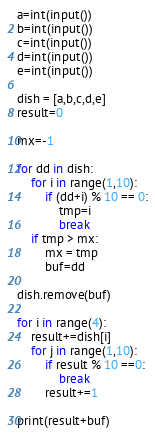Convert code to text. <code><loc_0><loc_0><loc_500><loc_500><_Python_>a=int(input())
b=int(input())
c=int(input())
d=int(input())
e=int(input())

dish = [a,b,c,d,e]
result=0

mx=-1

for dd in dish:
    for i in range(1,10):
        if (dd+i) % 10 == 0:
            tmp=i
            break
    if tmp > mx:
        mx = tmp
        buf=dd

dish.remove(buf)

for i in range(4):
    result+=dish[i]
    for j in range(1,10):
        if result % 10 ==0:
            break
        result+=1

print(result+buf)</code> 